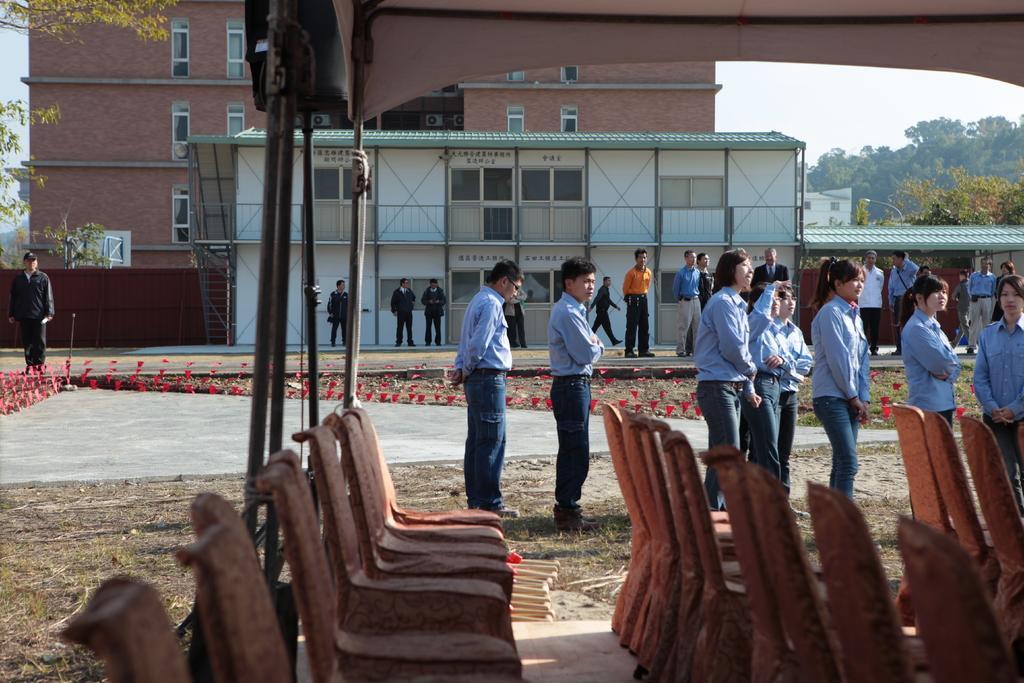Describe this image in one or two sentences. In this image I can see the chairs. I can see some people. In the background, I can see a building and the trees. 